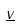Convert formula to latex. <formula><loc_0><loc_0><loc_500><loc_500>\underline { v }</formula> 